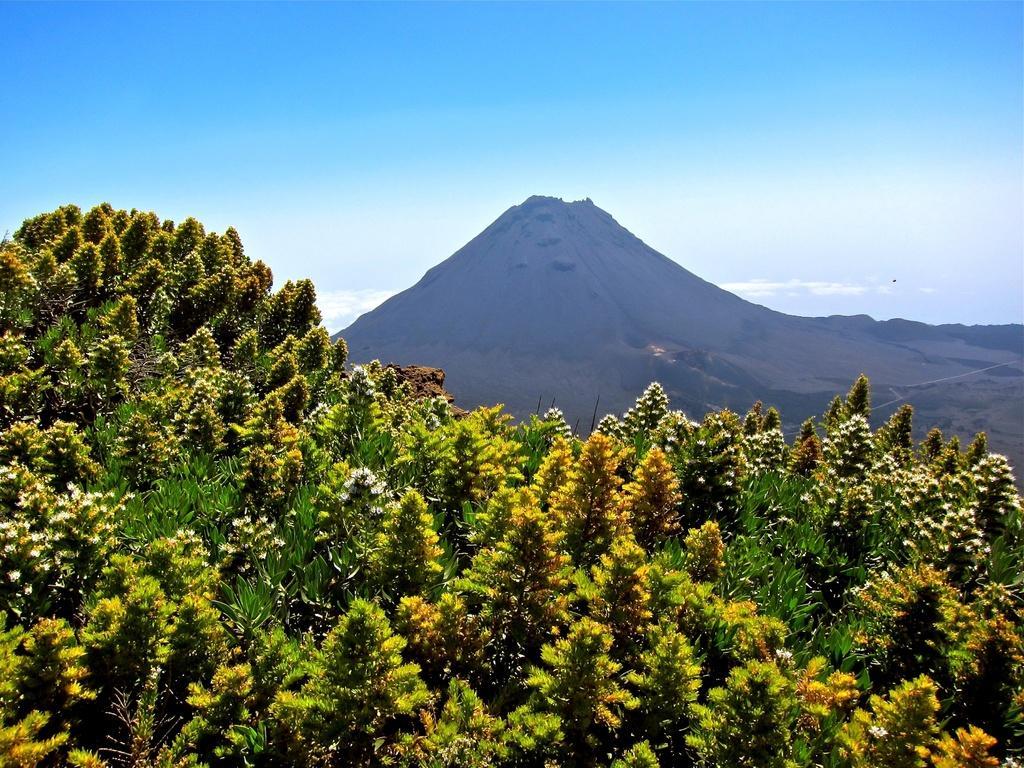Can you describe this image briefly? Here we can see plants and flowers. In the background there is a mountain and sky. 